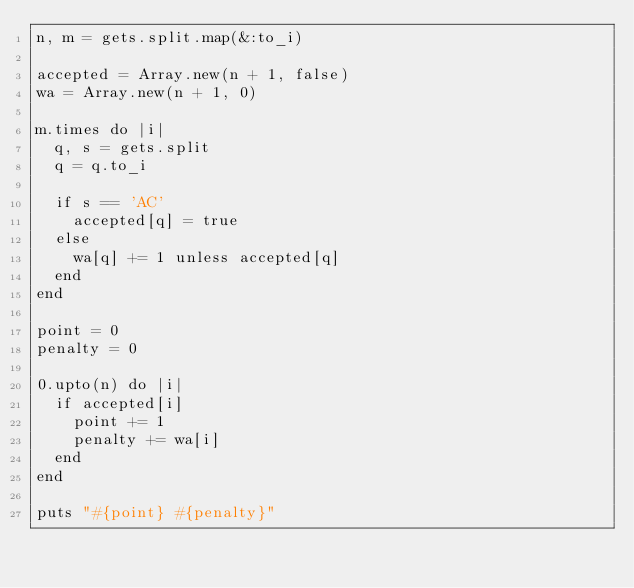<code> <loc_0><loc_0><loc_500><loc_500><_Ruby_>n, m = gets.split.map(&:to_i)

accepted = Array.new(n + 1, false)
wa = Array.new(n + 1, 0)

m.times do |i|
  q, s = gets.split
  q = q.to_i

  if s == 'AC'
    accepted[q] = true
  else
    wa[q] += 1 unless accepted[q]
  end
end

point = 0
penalty = 0

0.upto(n) do |i|
  if accepted[i]
    point += 1
    penalty += wa[i] 
  end
end

puts "#{point} #{penalty}"
</code> 